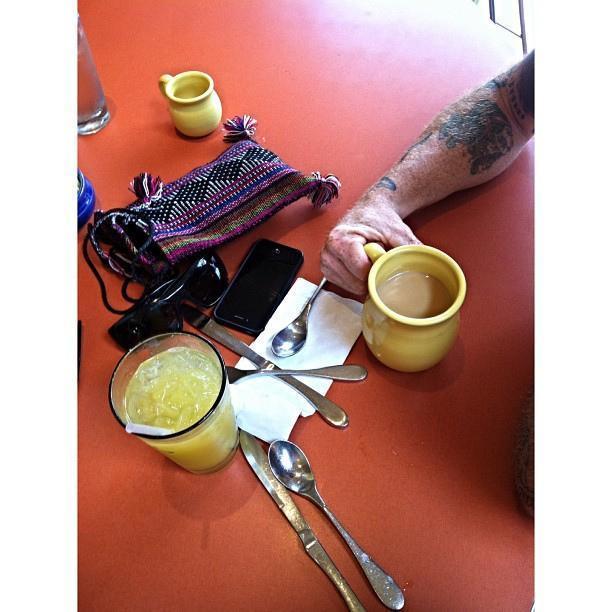How many spoons are on the table?
Give a very brief answer. 2. How many cups are there?
Give a very brief answer. 3. How many knives can be seen?
Give a very brief answer. 2. 